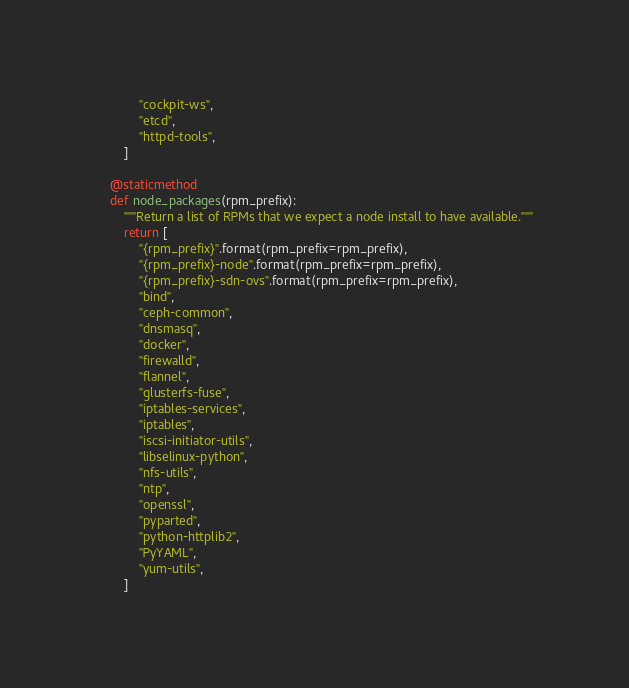<code> <loc_0><loc_0><loc_500><loc_500><_Python_>            "cockpit-ws",
            "etcd",
            "httpd-tools",
        ]

    @staticmethod
    def node_packages(rpm_prefix):
        """Return a list of RPMs that we expect a node install to have available."""
        return [
            "{rpm_prefix}".format(rpm_prefix=rpm_prefix),
            "{rpm_prefix}-node".format(rpm_prefix=rpm_prefix),
            "{rpm_prefix}-sdn-ovs".format(rpm_prefix=rpm_prefix),
            "bind",
            "ceph-common",
            "dnsmasq",
            "docker",
            "firewalld",
            "flannel",
            "glusterfs-fuse",
            "iptables-services",
            "iptables",
            "iscsi-initiator-utils",
            "libselinux-python",
            "nfs-utils",
            "ntp",
            "openssl",
            "pyparted",
            "python-httplib2",
            "PyYAML",
            "yum-utils",
        ]
</code> 